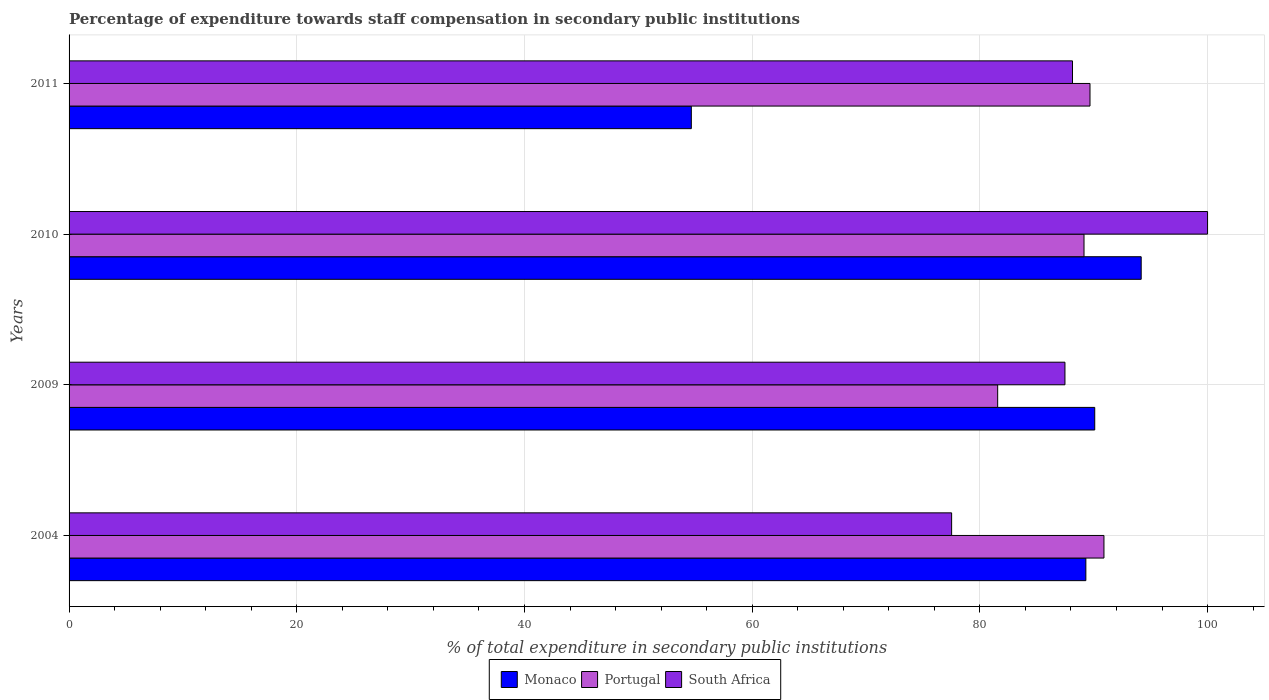How many different coloured bars are there?
Provide a short and direct response. 3. Are the number of bars per tick equal to the number of legend labels?
Offer a terse response. Yes. Are the number of bars on each tick of the Y-axis equal?
Offer a terse response. Yes. How many bars are there on the 3rd tick from the top?
Offer a very short reply. 3. What is the label of the 3rd group of bars from the top?
Provide a succinct answer. 2009. In how many cases, is the number of bars for a given year not equal to the number of legend labels?
Your response must be concise. 0. What is the percentage of expenditure towards staff compensation in Portugal in 2004?
Offer a terse response. 90.9. Across all years, what is the maximum percentage of expenditure towards staff compensation in Portugal?
Provide a succinct answer. 90.9. Across all years, what is the minimum percentage of expenditure towards staff compensation in South Africa?
Offer a very short reply. 77.52. What is the total percentage of expenditure towards staff compensation in Portugal in the graph?
Your answer should be compact. 351.28. What is the difference between the percentage of expenditure towards staff compensation in South Africa in 2009 and that in 2010?
Your answer should be very brief. -12.53. What is the difference between the percentage of expenditure towards staff compensation in Monaco in 2004 and the percentage of expenditure towards staff compensation in South Africa in 2011?
Make the answer very short. 1.17. What is the average percentage of expenditure towards staff compensation in Monaco per year?
Offer a very short reply. 82.06. In the year 2010, what is the difference between the percentage of expenditure towards staff compensation in Monaco and percentage of expenditure towards staff compensation in Portugal?
Ensure brevity in your answer.  5.02. In how many years, is the percentage of expenditure towards staff compensation in Portugal greater than 80 %?
Provide a short and direct response. 4. What is the ratio of the percentage of expenditure towards staff compensation in Portugal in 2004 to that in 2009?
Your answer should be very brief. 1.11. Is the difference between the percentage of expenditure towards staff compensation in Monaco in 2009 and 2011 greater than the difference between the percentage of expenditure towards staff compensation in Portugal in 2009 and 2011?
Your response must be concise. Yes. What is the difference between the highest and the second highest percentage of expenditure towards staff compensation in South Africa?
Make the answer very short. 11.86. What is the difference between the highest and the lowest percentage of expenditure towards staff compensation in Monaco?
Keep it short and to the point. 39.51. What does the 3rd bar from the top in 2009 represents?
Provide a short and direct response. Monaco. What does the 3rd bar from the bottom in 2010 represents?
Give a very brief answer. South Africa. Is it the case that in every year, the sum of the percentage of expenditure towards staff compensation in South Africa and percentage of expenditure towards staff compensation in Portugal is greater than the percentage of expenditure towards staff compensation in Monaco?
Give a very brief answer. Yes. Are all the bars in the graph horizontal?
Ensure brevity in your answer.  Yes. What is the difference between two consecutive major ticks on the X-axis?
Your answer should be very brief. 20. Are the values on the major ticks of X-axis written in scientific E-notation?
Ensure brevity in your answer.  No. Does the graph contain any zero values?
Offer a very short reply. No. Where does the legend appear in the graph?
Ensure brevity in your answer.  Bottom center. How many legend labels are there?
Keep it short and to the point. 3. What is the title of the graph?
Give a very brief answer. Percentage of expenditure towards staff compensation in secondary public institutions. Does "Least developed countries" appear as one of the legend labels in the graph?
Make the answer very short. No. What is the label or title of the X-axis?
Offer a terse response. % of total expenditure in secondary public institutions. What is the % of total expenditure in secondary public institutions in Monaco in 2004?
Your response must be concise. 89.31. What is the % of total expenditure in secondary public institutions of Portugal in 2004?
Offer a very short reply. 90.9. What is the % of total expenditure in secondary public institutions of South Africa in 2004?
Make the answer very short. 77.52. What is the % of total expenditure in secondary public institutions in Monaco in 2009?
Your response must be concise. 90.09. What is the % of total expenditure in secondary public institutions in Portugal in 2009?
Offer a terse response. 81.56. What is the % of total expenditure in secondary public institutions of South Africa in 2009?
Ensure brevity in your answer.  87.47. What is the % of total expenditure in secondary public institutions in Monaco in 2010?
Your response must be concise. 94.17. What is the % of total expenditure in secondary public institutions of Portugal in 2010?
Offer a very short reply. 89.15. What is the % of total expenditure in secondary public institutions of South Africa in 2010?
Make the answer very short. 100. What is the % of total expenditure in secondary public institutions in Monaco in 2011?
Keep it short and to the point. 54.66. What is the % of total expenditure in secondary public institutions in Portugal in 2011?
Ensure brevity in your answer.  89.67. What is the % of total expenditure in secondary public institutions in South Africa in 2011?
Your answer should be very brief. 88.14. Across all years, what is the maximum % of total expenditure in secondary public institutions of Monaco?
Your response must be concise. 94.17. Across all years, what is the maximum % of total expenditure in secondary public institutions in Portugal?
Give a very brief answer. 90.9. Across all years, what is the maximum % of total expenditure in secondary public institutions in South Africa?
Your answer should be compact. 100. Across all years, what is the minimum % of total expenditure in secondary public institutions of Monaco?
Keep it short and to the point. 54.66. Across all years, what is the minimum % of total expenditure in secondary public institutions of Portugal?
Provide a short and direct response. 81.56. Across all years, what is the minimum % of total expenditure in secondary public institutions in South Africa?
Give a very brief answer. 77.52. What is the total % of total expenditure in secondary public institutions in Monaco in the graph?
Give a very brief answer. 328.22. What is the total % of total expenditure in secondary public institutions in Portugal in the graph?
Ensure brevity in your answer.  351.28. What is the total % of total expenditure in secondary public institutions of South Africa in the graph?
Your response must be concise. 353.13. What is the difference between the % of total expenditure in secondary public institutions in Monaco in 2004 and that in 2009?
Provide a short and direct response. -0.78. What is the difference between the % of total expenditure in secondary public institutions in Portugal in 2004 and that in 2009?
Your answer should be compact. 9.33. What is the difference between the % of total expenditure in secondary public institutions in South Africa in 2004 and that in 2009?
Give a very brief answer. -9.95. What is the difference between the % of total expenditure in secondary public institutions in Monaco in 2004 and that in 2010?
Your response must be concise. -4.86. What is the difference between the % of total expenditure in secondary public institutions of Portugal in 2004 and that in 2010?
Your response must be concise. 1.75. What is the difference between the % of total expenditure in secondary public institutions in South Africa in 2004 and that in 2010?
Keep it short and to the point. -22.48. What is the difference between the % of total expenditure in secondary public institutions in Monaco in 2004 and that in 2011?
Provide a succinct answer. 34.65. What is the difference between the % of total expenditure in secondary public institutions of Portugal in 2004 and that in 2011?
Ensure brevity in your answer.  1.22. What is the difference between the % of total expenditure in secondary public institutions of South Africa in 2004 and that in 2011?
Your answer should be compact. -10.62. What is the difference between the % of total expenditure in secondary public institutions of Monaco in 2009 and that in 2010?
Provide a short and direct response. -4.08. What is the difference between the % of total expenditure in secondary public institutions in Portugal in 2009 and that in 2010?
Provide a succinct answer. -7.58. What is the difference between the % of total expenditure in secondary public institutions of South Africa in 2009 and that in 2010?
Ensure brevity in your answer.  -12.53. What is the difference between the % of total expenditure in secondary public institutions in Monaco in 2009 and that in 2011?
Offer a terse response. 35.43. What is the difference between the % of total expenditure in secondary public institutions of Portugal in 2009 and that in 2011?
Your response must be concise. -8.11. What is the difference between the % of total expenditure in secondary public institutions of South Africa in 2009 and that in 2011?
Provide a short and direct response. -0.66. What is the difference between the % of total expenditure in secondary public institutions of Monaco in 2010 and that in 2011?
Your answer should be very brief. 39.51. What is the difference between the % of total expenditure in secondary public institutions in Portugal in 2010 and that in 2011?
Provide a short and direct response. -0.53. What is the difference between the % of total expenditure in secondary public institutions in South Africa in 2010 and that in 2011?
Make the answer very short. 11.86. What is the difference between the % of total expenditure in secondary public institutions in Monaco in 2004 and the % of total expenditure in secondary public institutions in Portugal in 2009?
Provide a short and direct response. 7.75. What is the difference between the % of total expenditure in secondary public institutions in Monaco in 2004 and the % of total expenditure in secondary public institutions in South Africa in 2009?
Your answer should be compact. 1.84. What is the difference between the % of total expenditure in secondary public institutions in Portugal in 2004 and the % of total expenditure in secondary public institutions in South Africa in 2009?
Ensure brevity in your answer.  3.43. What is the difference between the % of total expenditure in secondary public institutions of Monaco in 2004 and the % of total expenditure in secondary public institutions of Portugal in 2010?
Offer a very short reply. 0.16. What is the difference between the % of total expenditure in secondary public institutions of Monaco in 2004 and the % of total expenditure in secondary public institutions of South Africa in 2010?
Ensure brevity in your answer.  -10.69. What is the difference between the % of total expenditure in secondary public institutions in Portugal in 2004 and the % of total expenditure in secondary public institutions in South Africa in 2010?
Provide a succinct answer. -9.1. What is the difference between the % of total expenditure in secondary public institutions of Monaco in 2004 and the % of total expenditure in secondary public institutions of Portugal in 2011?
Ensure brevity in your answer.  -0.36. What is the difference between the % of total expenditure in secondary public institutions of Monaco in 2004 and the % of total expenditure in secondary public institutions of South Africa in 2011?
Offer a very short reply. 1.17. What is the difference between the % of total expenditure in secondary public institutions in Portugal in 2004 and the % of total expenditure in secondary public institutions in South Africa in 2011?
Provide a short and direct response. 2.76. What is the difference between the % of total expenditure in secondary public institutions of Monaco in 2009 and the % of total expenditure in secondary public institutions of Portugal in 2010?
Provide a succinct answer. 0.94. What is the difference between the % of total expenditure in secondary public institutions in Monaco in 2009 and the % of total expenditure in secondary public institutions in South Africa in 2010?
Keep it short and to the point. -9.91. What is the difference between the % of total expenditure in secondary public institutions in Portugal in 2009 and the % of total expenditure in secondary public institutions in South Africa in 2010?
Provide a succinct answer. -18.44. What is the difference between the % of total expenditure in secondary public institutions of Monaco in 2009 and the % of total expenditure in secondary public institutions of Portugal in 2011?
Give a very brief answer. 0.42. What is the difference between the % of total expenditure in secondary public institutions in Monaco in 2009 and the % of total expenditure in secondary public institutions in South Africa in 2011?
Provide a succinct answer. 1.95. What is the difference between the % of total expenditure in secondary public institutions in Portugal in 2009 and the % of total expenditure in secondary public institutions in South Africa in 2011?
Offer a terse response. -6.57. What is the difference between the % of total expenditure in secondary public institutions in Monaco in 2010 and the % of total expenditure in secondary public institutions in Portugal in 2011?
Offer a very short reply. 4.5. What is the difference between the % of total expenditure in secondary public institutions of Monaco in 2010 and the % of total expenditure in secondary public institutions of South Africa in 2011?
Your answer should be compact. 6.03. What is the difference between the % of total expenditure in secondary public institutions of Portugal in 2010 and the % of total expenditure in secondary public institutions of South Africa in 2011?
Provide a succinct answer. 1.01. What is the average % of total expenditure in secondary public institutions of Monaco per year?
Offer a terse response. 82.06. What is the average % of total expenditure in secondary public institutions in Portugal per year?
Make the answer very short. 87.82. What is the average % of total expenditure in secondary public institutions in South Africa per year?
Ensure brevity in your answer.  88.28. In the year 2004, what is the difference between the % of total expenditure in secondary public institutions of Monaco and % of total expenditure in secondary public institutions of Portugal?
Provide a succinct answer. -1.59. In the year 2004, what is the difference between the % of total expenditure in secondary public institutions in Monaco and % of total expenditure in secondary public institutions in South Africa?
Give a very brief answer. 11.79. In the year 2004, what is the difference between the % of total expenditure in secondary public institutions in Portugal and % of total expenditure in secondary public institutions in South Africa?
Offer a terse response. 13.38. In the year 2009, what is the difference between the % of total expenditure in secondary public institutions of Monaco and % of total expenditure in secondary public institutions of Portugal?
Make the answer very short. 8.52. In the year 2009, what is the difference between the % of total expenditure in secondary public institutions in Monaco and % of total expenditure in secondary public institutions in South Africa?
Your answer should be very brief. 2.62. In the year 2009, what is the difference between the % of total expenditure in secondary public institutions in Portugal and % of total expenditure in secondary public institutions in South Africa?
Make the answer very short. -5.91. In the year 2010, what is the difference between the % of total expenditure in secondary public institutions in Monaco and % of total expenditure in secondary public institutions in Portugal?
Keep it short and to the point. 5.02. In the year 2010, what is the difference between the % of total expenditure in secondary public institutions in Monaco and % of total expenditure in secondary public institutions in South Africa?
Give a very brief answer. -5.83. In the year 2010, what is the difference between the % of total expenditure in secondary public institutions of Portugal and % of total expenditure in secondary public institutions of South Africa?
Ensure brevity in your answer.  -10.85. In the year 2011, what is the difference between the % of total expenditure in secondary public institutions in Monaco and % of total expenditure in secondary public institutions in Portugal?
Keep it short and to the point. -35.02. In the year 2011, what is the difference between the % of total expenditure in secondary public institutions in Monaco and % of total expenditure in secondary public institutions in South Africa?
Ensure brevity in your answer.  -33.48. In the year 2011, what is the difference between the % of total expenditure in secondary public institutions of Portugal and % of total expenditure in secondary public institutions of South Africa?
Give a very brief answer. 1.54. What is the ratio of the % of total expenditure in secondary public institutions of Portugal in 2004 to that in 2009?
Give a very brief answer. 1.11. What is the ratio of the % of total expenditure in secondary public institutions of South Africa in 2004 to that in 2009?
Offer a very short reply. 0.89. What is the ratio of the % of total expenditure in secondary public institutions in Monaco in 2004 to that in 2010?
Keep it short and to the point. 0.95. What is the ratio of the % of total expenditure in secondary public institutions in Portugal in 2004 to that in 2010?
Make the answer very short. 1.02. What is the ratio of the % of total expenditure in secondary public institutions of South Africa in 2004 to that in 2010?
Your response must be concise. 0.78. What is the ratio of the % of total expenditure in secondary public institutions in Monaco in 2004 to that in 2011?
Your answer should be very brief. 1.63. What is the ratio of the % of total expenditure in secondary public institutions in Portugal in 2004 to that in 2011?
Offer a terse response. 1.01. What is the ratio of the % of total expenditure in secondary public institutions of South Africa in 2004 to that in 2011?
Your answer should be very brief. 0.88. What is the ratio of the % of total expenditure in secondary public institutions in Monaco in 2009 to that in 2010?
Offer a terse response. 0.96. What is the ratio of the % of total expenditure in secondary public institutions in Portugal in 2009 to that in 2010?
Provide a short and direct response. 0.91. What is the ratio of the % of total expenditure in secondary public institutions in South Africa in 2009 to that in 2010?
Your answer should be very brief. 0.87. What is the ratio of the % of total expenditure in secondary public institutions in Monaco in 2009 to that in 2011?
Your answer should be very brief. 1.65. What is the ratio of the % of total expenditure in secondary public institutions in Portugal in 2009 to that in 2011?
Offer a very short reply. 0.91. What is the ratio of the % of total expenditure in secondary public institutions of Monaco in 2010 to that in 2011?
Provide a short and direct response. 1.72. What is the ratio of the % of total expenditure in secondary public institutions in Portugal in 2010 to that in 2011?
Provide a succinct answer. 0.99. What is the ratio of the % of total expenditure in secondary public institutions in South Africa in 2010 to that in 2011?
Give a very brief answer. 1.13. What is the difference between the highest and the second highest % of total expenditure in secondary public institutions of Monaco?
Your answer should be very brief. 4.08. What is the difference between the highest and the second highest % of total expenditure in secondary public institutions in Portugal?
Your response must be concise. 1.22. What is the difference between the highest and the second highest % of total expenditure in secondary public institutions in South Africa?
Provide a succinct answer. 11.86. What is the difference between the highest and the lowest % of total expenditure in secondary public institutions in Monaco?
Give a very brief answer. 39.51. What is the difference between the highest and the lowest % of total expenditure in secondary public institutions in Portugal?
Ensure brevity in your answer.  9.33. What is the difference between the highest and the lowest % of total expenditure in secondary public institutions in South Africa?
Offer a terse response. 22.48. 